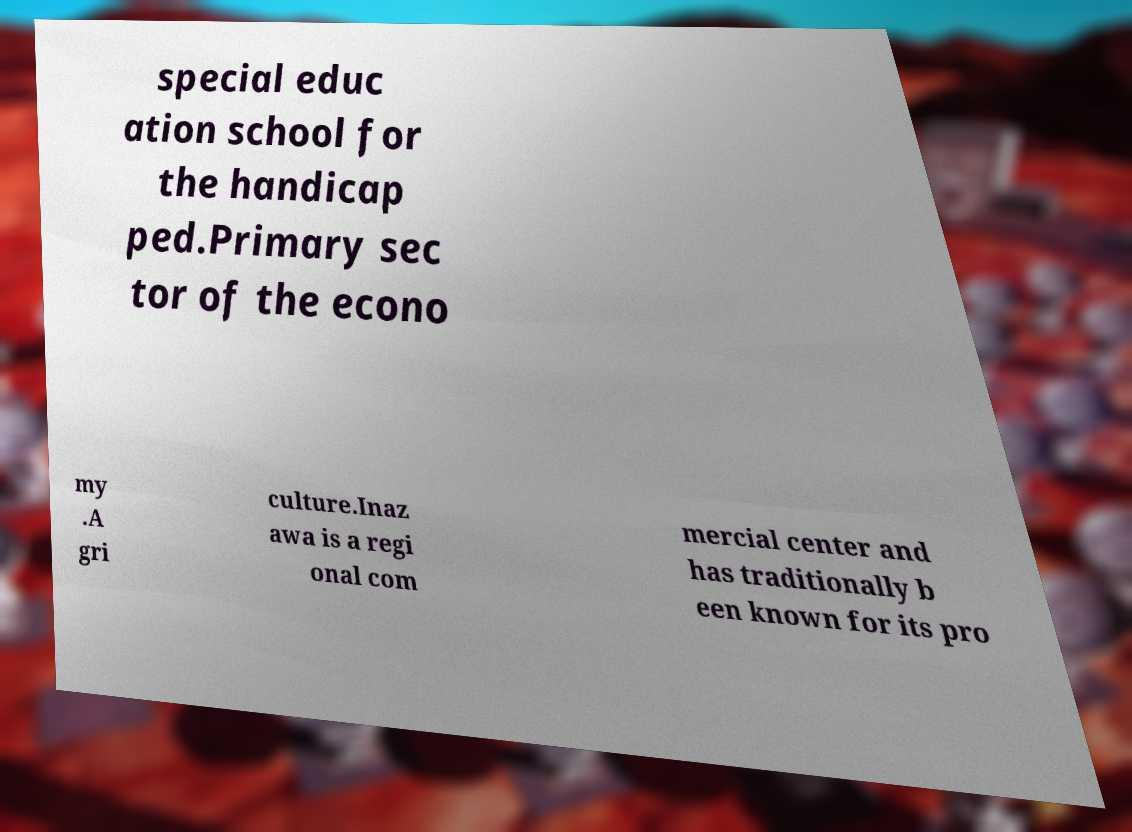Please identify and transcribe the text found in this image. special educ ation school for the handicap ped.Primary sec tor of the econo my .A gri culture.Inaz awa is a regi onal com mercial center and has traditionally b een known for its pro 